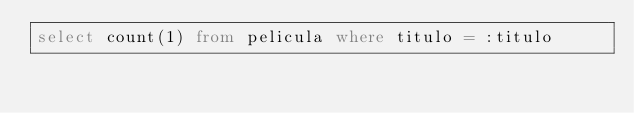Convert code to text. <code><loc_0><loc_0><loc_500><loc_500><_SQL_>select count(1) from pelicula where titulo = :titulo</code> 